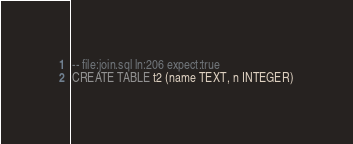Convert code to text. <code><loc_0><loc_0><loc_500><loc_500><_SQL_>-- file:join.sql ln:206 expect:true
CREATE TABLE t2 (name TEXT, n INTEGER)
</code> 